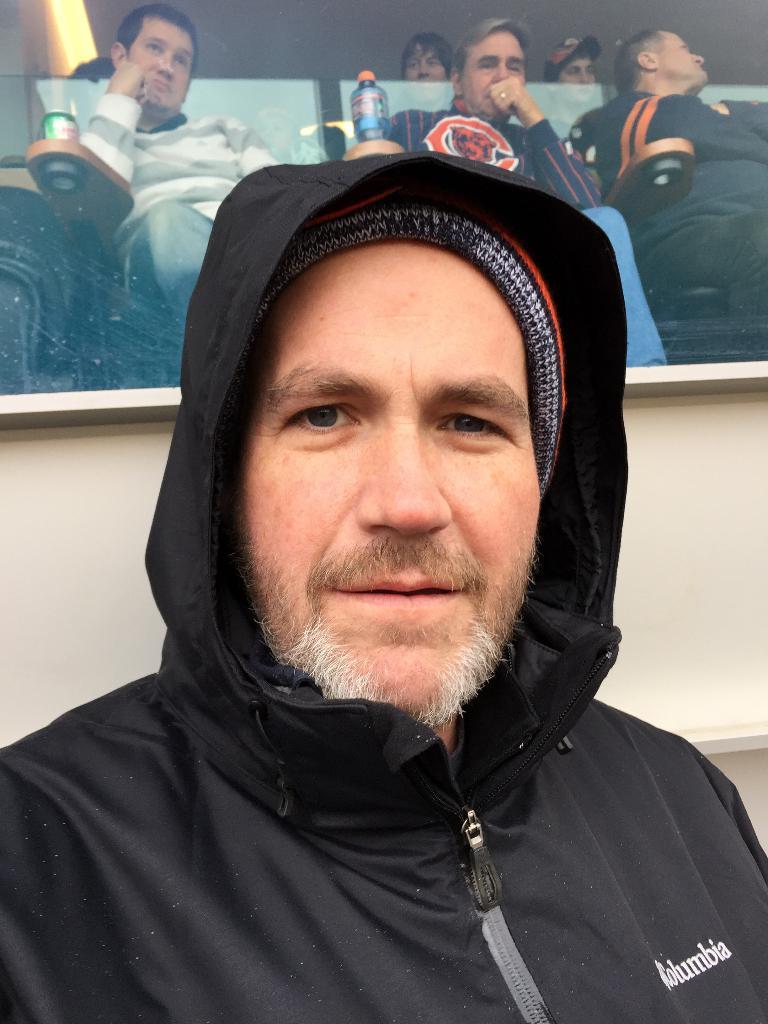Can you describe this image briefly? In the foreground of this image, there is a man in black over coat and in the background, there are few persons sitting on chair. 